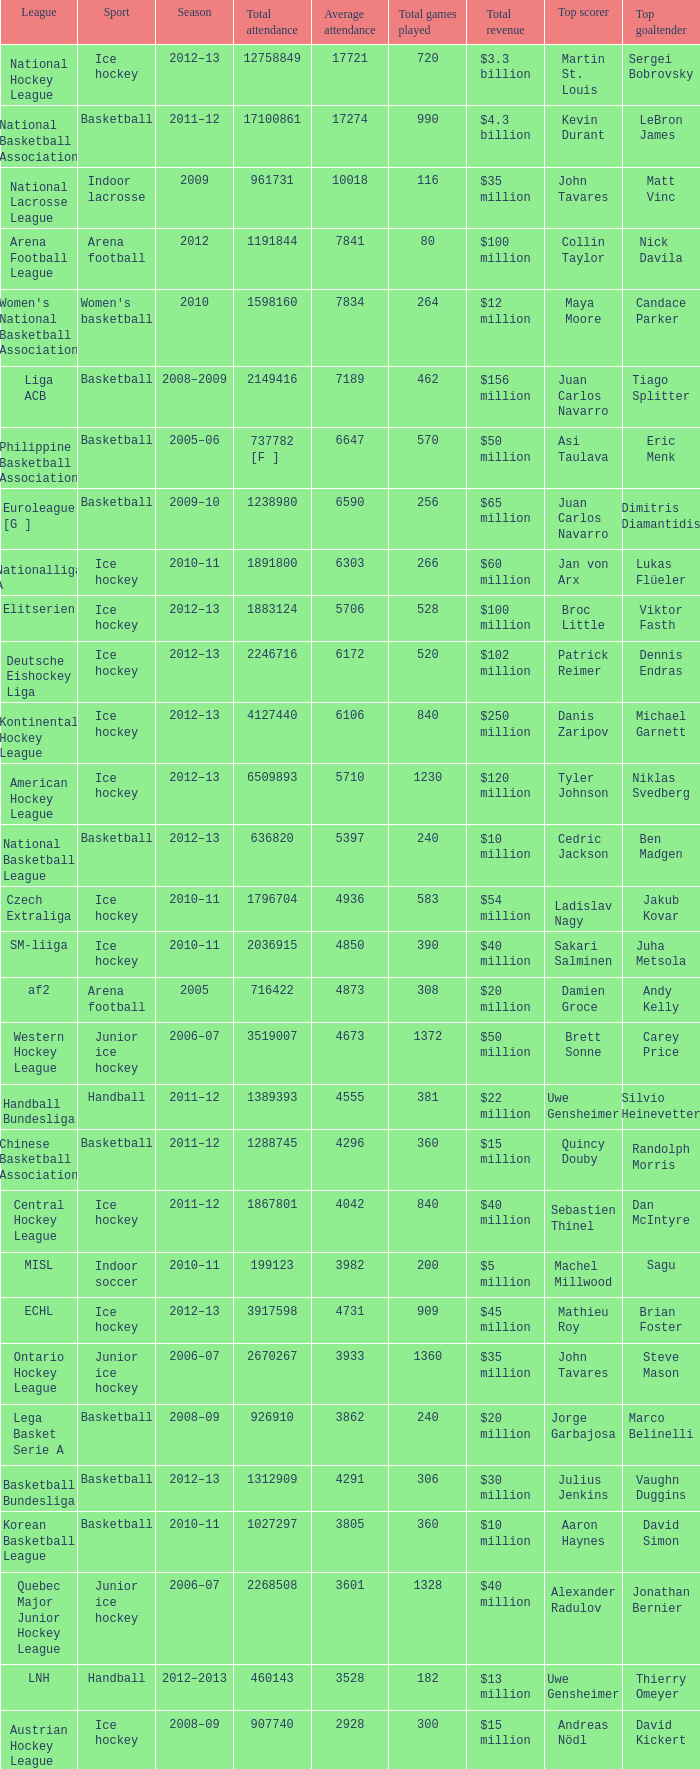What was the highest average attendance in the 2009 season? 10018.0. 